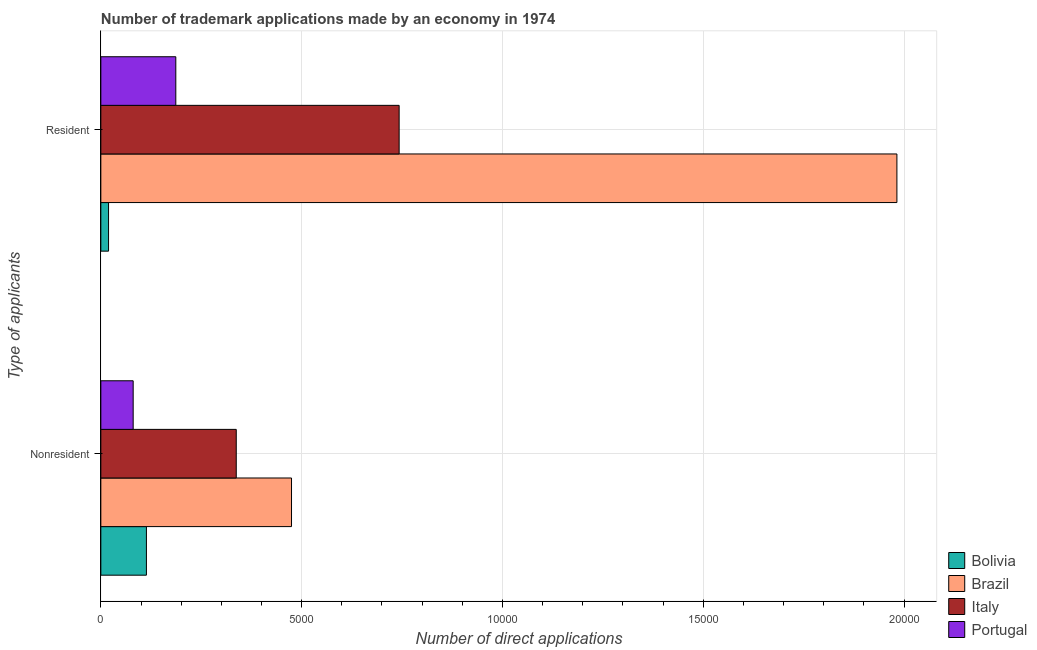How many different coloured bars are there?
Make the answer very short. 4. How many bars are there on the 1st tick from the top?
Give a very brief answer. 4. What is the label of the 2nd group of bars from the top?
Your response must be concise. Nonresident. What is the number of trademark applications made by non residents in Bolivia?
Make the answer very short. 1135. Across all countries, what is the maximum number of trademark applications made by non residents?
Provide a succinct answer. 4748. Across all countries, what is the minimum number of trademark applications made by non residents?
Your answer should be compact. 805. In which country was the number of trademark applications made by residents maximum?
Offer a terse response. Brazil. In which country was the number of trademark applications made by non residents minimum?
Provide a succinct answer. Portugal. What is the total number of trademark applications made by residents in the graph?
Provide a short and direct response. 2.93e+04. What is the difference between the number of trademark applications made by non residents in Italy and that in Portugal?
Give a very brief answer. 2567. What is the difference between the number of trademark applications made by residents in Italy and the number of trademark applications made by non residents in Portugal?
Provide a short and direct response. 6623. What is the average number of trademark applications made by residents per country?
Your answer should be compact. 7327.5. What is the difference between the number of trademark applications made by non residents and number of trademark applications made by residents in Portugal?
Make the answer very short. -1062. In how many countries, is the number of trademark applications made by non residents greater than 14000 ?
Your answer should be very brief. 0. What is the ratio of the number of trademark applications made by non residents in Brazil to that in Bolivia?
Make the answer very short. 4.18. Is the number of trademark applications made by non residents in Portugal less than that in Brazil?
Ensure brevity in your answer.  Yes. In how many countries, is the number of trademark applications made by non residents greater than the average number of trademark applications made by non residents taken over all countries?
Provide a short and direct response. 2. How many bars are there?
Offer a very short reply. 8. Are all the bars in the graph horizontal?
Your response must be concise. Yes. What is the difference between two consecutive major ticks on the X-axis?
Offer a terse response. 5000. Are the values on the major ticks of X-axis written in scientific E-notation?
Provide a succinct answer. No. Does the graph contain any zero values?
Your answer should be very brief. No. Does the graph contain grids?
Ensure brevity in your answer.  Yes. Where does the legend appear in the graph?
Give a very brief answer. Bottom right. How many legend labels are there?
Your response must be concise. 4. How are the legend labels stacked?
Your response must be concise. Vertical. What is the title of the graph?
Offer a very short reply. Number of trademark applications made by an economy in 1974. What is the label or title of the X-axis?
Offer a very short reply. Number of direct applications. What is the label or title of the Y-axis?
Offer a terse response. Type of applicants. What is the Number of direct applications in Bolivia in Nonresident?
Provide a succinct answer. 1135. What is the Number of direct applications in Brazil in Nonresident?
Give a very brief answer. 4748. What is the Number of direct applications in Italy in Nonresident?
Ensure brevity in your answer.  3372. What is the Number of direct applications of Portugal in Nonresident?
Offer a very short reply. 805. What is the Number of direct applications in Bolivia in Resident?
Give a very brief answer. 192. What is the Number of direct applications in Brazil in Resident?
Keep it short and to the point. 1.98e+04. What is the Number of direct applications of Italy in Resident?
Provide a succinct answer. 7428. What is the Number of direct applications of Portugal in Resident?
Your response must be concise. 1867. Across all Type of applicants, what is the maximum Number of direct applications in Bolivia?
Offer a terse response. 1135. Across all Type of applicants, what is the maximum Number of direct applications in Brazil?
Provide a short and direct response. 1.98e+04. Across all Type of applicants, what is the maximum Number of direct applications in Italy?
Ensure brevity in your answer.  7428. Across all Type of applicants, what is the maximum Number of direct applications of Portugal?
Provide a short and direct response. 1867. Across all Type of applicants, what is the minimum Number of direct applications of Bolivia?
Give a very brief answer. 192. Across all Type of applicants, what is the minimum Number of direct applications of Brazil?
Provide a short and direct response. 4748. Across all Type of applicants, what is the minimum Number of direct applications in Italy?
Your answer should be very brief. 3372. Across all Type of applicants, what is the minimum Number of direct applications in Portugal?
Provide a succinct answer. 805. What is the total Number of direct applications in Bolivia in the graph?
Ensure brevity in your answer.  1327. What is the total Number of direct applications in Brazil in the graph?
Provide a short and direct response. 2.46e+04. What is the total Number of direct applications in Italy in the graph?
Provide a short and direct response. 1.08e+04. What is the total Number of direct applications of Portugal in the graph?
Offer a very short reply. 2672. What is the difference between the Number of direct applications in Bolivia in Nonresident and that in Resident?
Give a very brief answer. 943. What is the difference between the Number of direct applications of Brazil in Nonresident and that in Resident?
Provide a short and direct response. -1.51e+04. What is the difference between the Number of direct applications in Italy in Nonresident and that in Resident?
Make the answer very short. -4056. What is the difference between the Number of direct applications of Portugal in Nonresident and that in Resident?
Keep it short and to the point. -1062. What is the difference between the Number of direct applications in Bolivia in Nonresident and the Number of direct applications in Brazil in Resident?
Make the answer very short. -1.87e+04. What is the difference between the Number of direct applications of Bolivia in Nonresident and the Number of direct applications of Italy in Resident?
Provide a short and direct response. -6293. What is the difference between the Number of direct applications in Bolivia in Nonresident and the Number of direct applications in Portugal in Resident?
Offer a terse response. -732. What is the difference between the Number of direct applications of Brazil in Nonresident and the Number of direct applications of Italy in Resident?
Ensure brevity in your answer.  -2680. What is the difference between the Number of direct applications of Brazil in Nonresident and the Number of direct applications of Portugal in Resident?
Your response must be concise. 2881. What is the difference between the Number of direct applications in Italy in Nonresident and the Number of direct applications in Portugal in Resident?
Make the answer very short. 1505. What is the average Number of direct applications in Bolivia per Type of applicants?
Ensure brevity in your answer.  663.5. What is the average Number of direct applications of Brazil per Type of applicants?
Provide a short and direct response. 1.23e+04. What is the average Number of direct applications in Italy per Type of applicants?
Ensure brevity in your answer.  5400. What is the average Number of direct applications in Portugal per Type of applicants?
Your answer should be compact. 1336. What is the difference between the Number of direct applications in Bolivia and Number of direct applications in Brazil in Nonresident?
Give a very brief answer. -3613. What is the difference between the Number of direct applications of Bolivia and Number of direct applications of Italy in Nonresident?
Your answer should be compact. -2237. What is the difference between the Number of direct applications of Bolivia and Number of direct applications of Portugal in Nonresident?
Offer a very short reply. 330. What is the difference between the Number of direct applications of Brazil and Number of direct applications of Italy in Nonresident?
Offer a terse response. 1376. What is the difference between the Number of direct applications of Brazil and Number of direct applications of Portugal in Nonresident?
Give a very brief answer. 3943. What is the difference between the Number of direct applications of Italy and Number of direct applications of Portugal in Nonresident?
Ensure brevity in your answer.  2567. What is the difference between the Number of direct applications of Bolivia and Number of direct applications of Brazil in Resident?
Ensure brevity in your answer.  -1.96e+04. What is the difference between the Number of direct applications of Bolivia and Number of direct applications of Italy in Resident?
Give a very brief answer. -7236. What is the difference between the Number of direct applications in Bolivia and Number of direct applications in Portugal in Resident?
Your response must be concise. -1675. What is the difference between the Number of direct applications in Brazil and Number of direct applications in Italy in Resident?
Offer a terse response. 1.24e+04. What is the difference between the Number of direct applications of Brazil and Number of direct applications of Portugal in Resident?
Make the answer very short. 1.80e+04. What is the difference between the Number of direct applications in Italy and Number of direct applications in Portugal in Resident?
Provide a succinct answer. 5561. What is the ratio of the Number of direct applications of Bolivia in Nonresident to that in Resident?
Offer a terse response. 5.91. What is the ratio of the Number of direct applications of Brazil in Nonresident to that in Resident?
Ensure brevity in your answer.  0.24. What is the ratio of the Number of direct applications in Italy in Nonresident to that in Resident?
Make the answer very short. 0.45. What is the ratio of the Number of direct applications of Portugal in Nonresident to that in Resident?
Provide a short and direct response. 0.43. What is the difference between the highest and the second highest Number of direct applications of Bolivia?
Ensure brevity in your answer.  943. What is the difference between the highest and the second highest Number of direct applications in Brazil?
Your answer should be compact. 1.51e+04. What is the difference between the highest and the second highest Number of direct applications in Italy?
Give a very brief answer. 4056. What is the difference between the highest and the second highest Number of direct applications of Portugal?
Provide a succinct answer. 1062. What is the difference between the highest and the lowest Number of direct applications in Bolivia?
Provide a short and direct response. 943. What is the difference between the highest and the lowest Number of direct applications in Brazil?
Give a very brief answer. 1.51e+04. What is the difference between the highest and the lowest Number of direct applications of Italy?
Provide a succinct answer. 4056. What is the difference between the highest and the lowest Number of direct applications of Portugal?
Provide a succinct answer. 1062. 